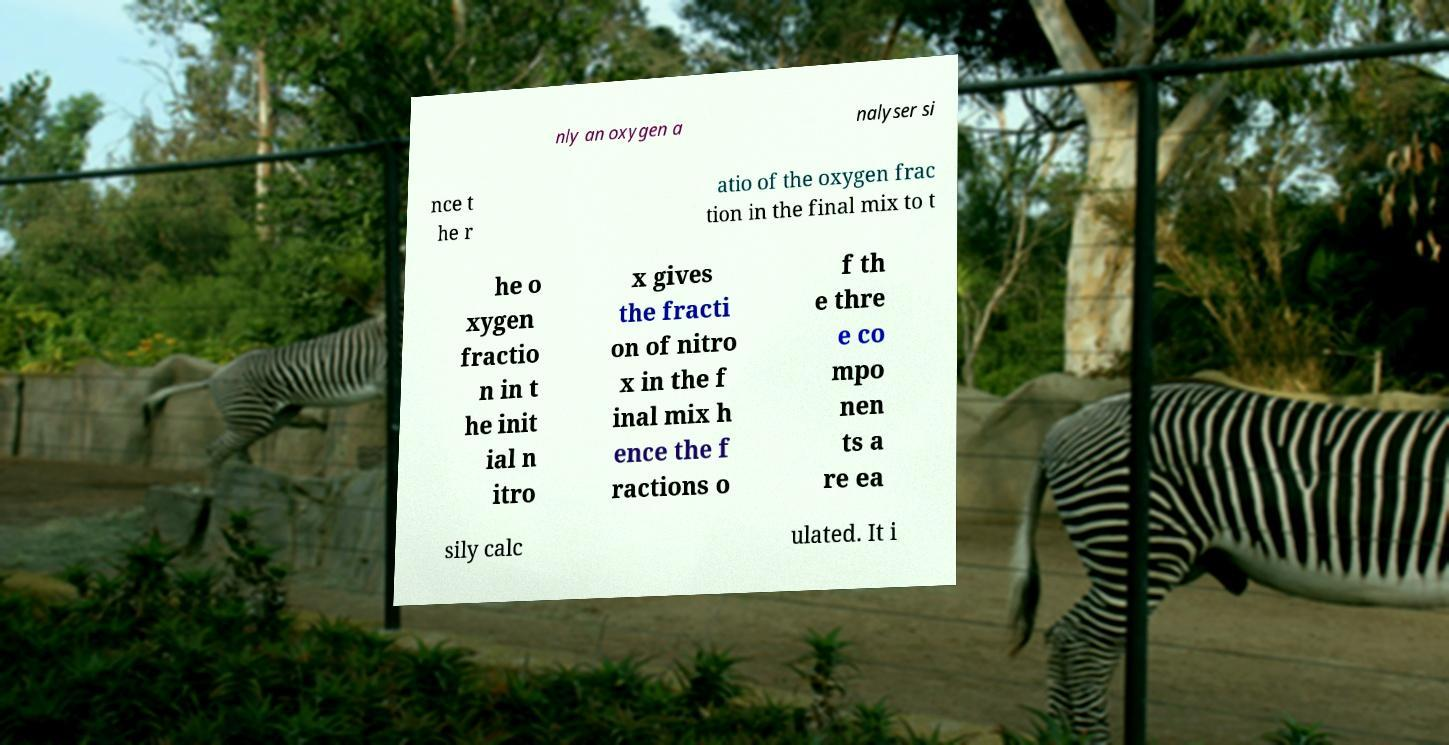Can you accurately transcribe the text from the provided image for me? nly an oxygen a nalyser si nce t he r atio of the oxygen frac tion in the final mix to t he o xygen fractio n in t he init ial n itro x gives the fracti on of nitro x in the f inal mix h ence the f ractions o f th e thre e co mpo nen ts a re ea sily calc ulated. It i 